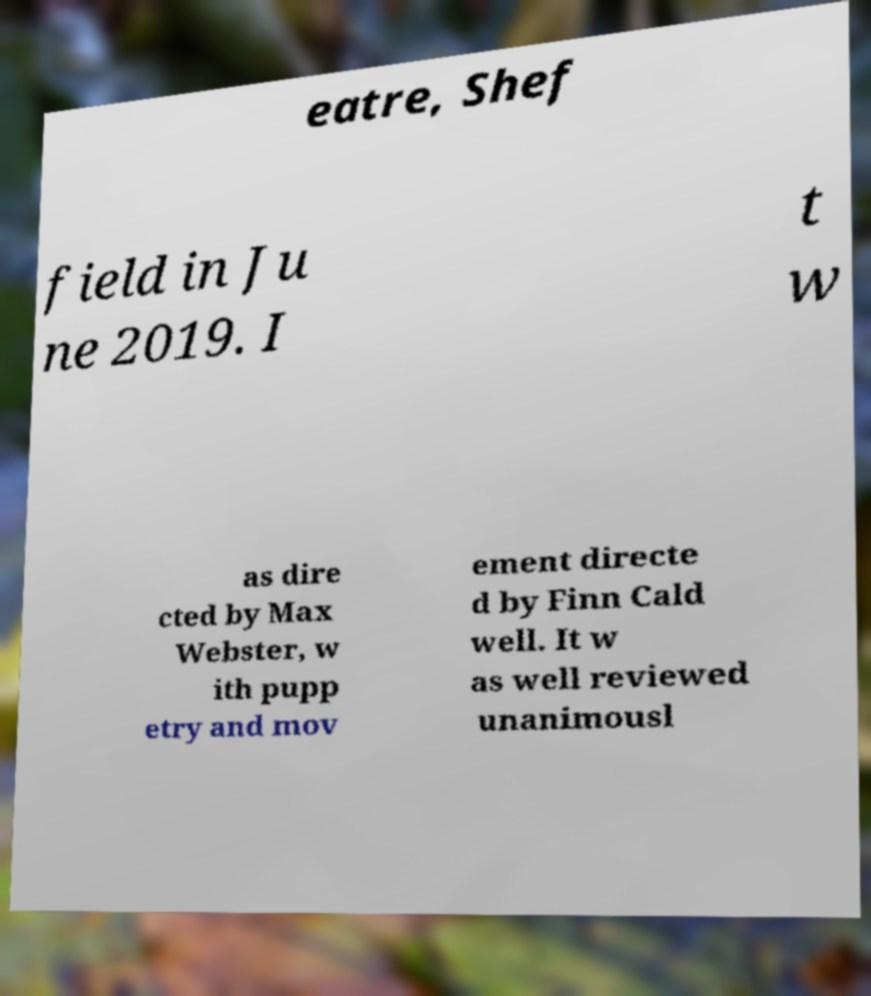Can you read and provide the text displayed in the image?This photo seems to have some interesting text. Can you extract and type it out for me? eatre, Shef field in Ju ne 2019. I t w as dire cted by Max Webster, w ith pupp etry and mov ement directe d by Finn Cald well. It w as well reviewed unanimousl 